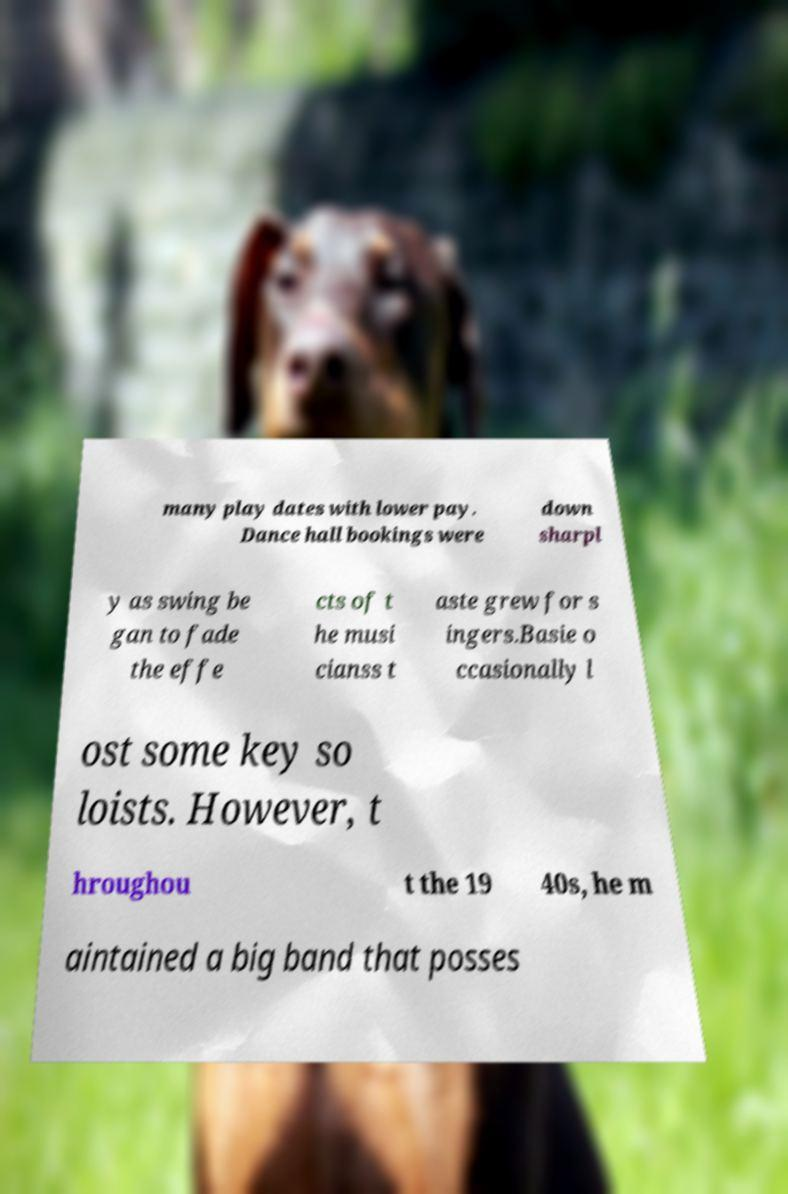For documentation purposes, I need the text within this image transcribed. Could you provide that? many play dates with lower pay. Dance hall bookings were down sharpl y as swing be gan to fade the effe cts of t he musi cianss t aste grew for s ingers.Basie o ccasionally l ost some key so loists. However, t hroughou t the 19 40s, he m aintained a big band that posses 